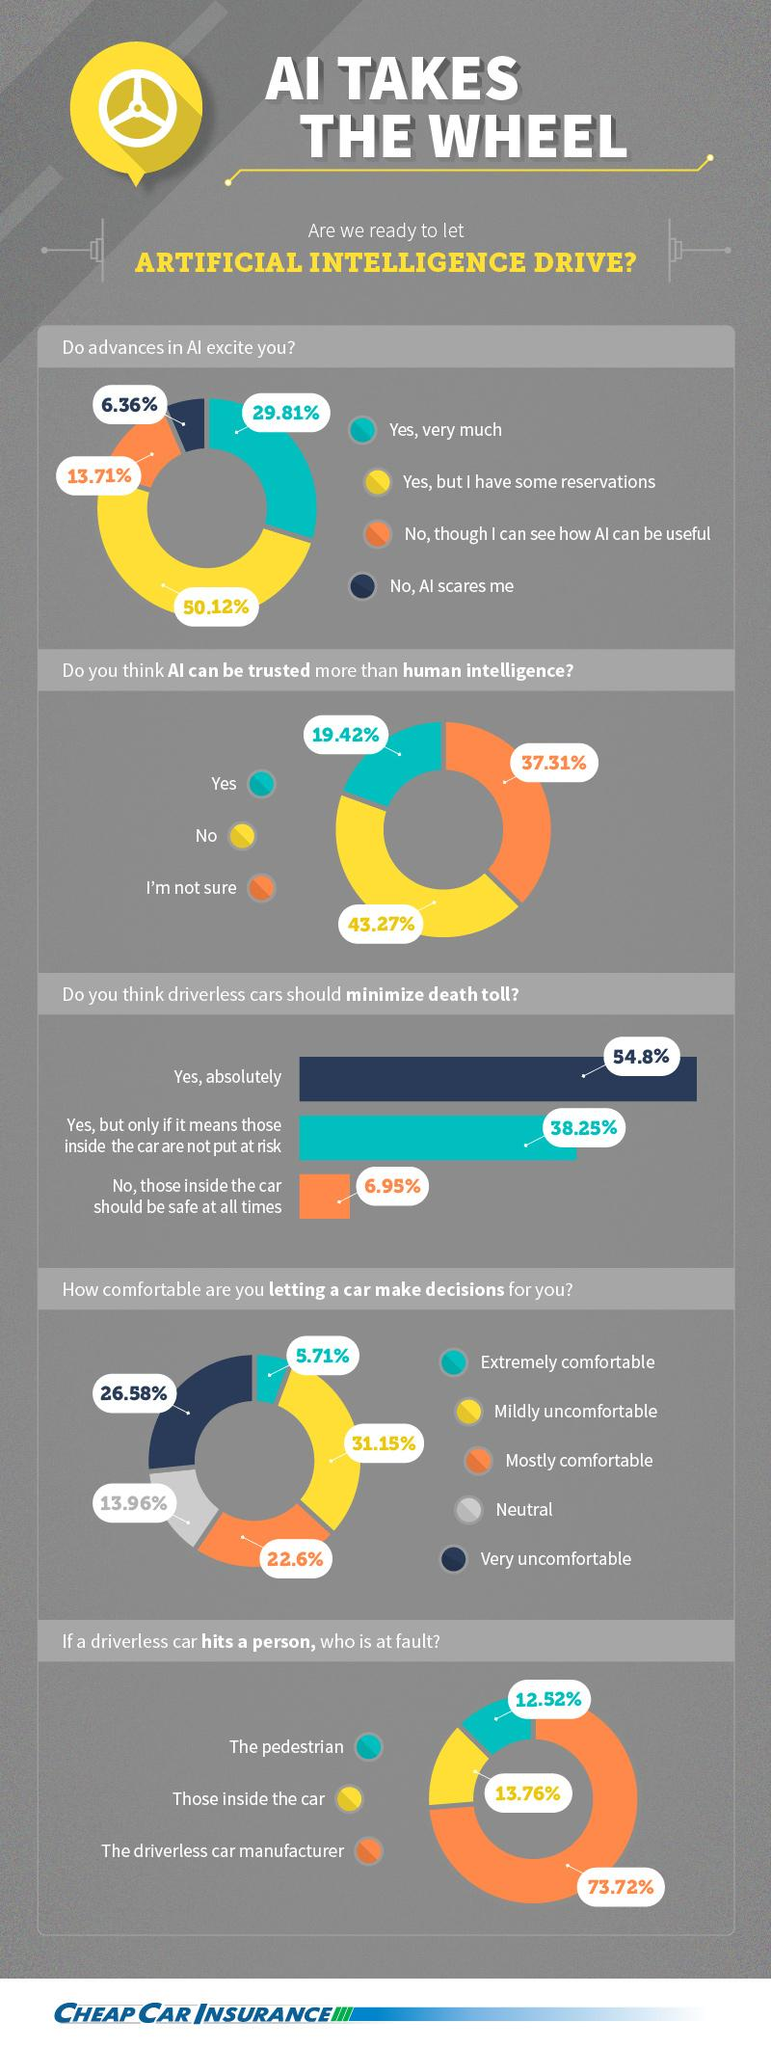Identify some key points in this picture. The overwhelming majority of people believe that the responsibility for an autonomous vehicle hitting a pedestrian rests with the manufacturer of the vehicle. It is the opinion of 26.58% of people that it is very uncomfortable to let a car make decisions for them. The majority of people say that AI cannot be trusted more than human intelligence. A recent survey reveals that 29.81% of people are very much excited about advances in AI. According to a recent survey, only 19.42% of people believe that AI can be trusted more than human intelligence. 